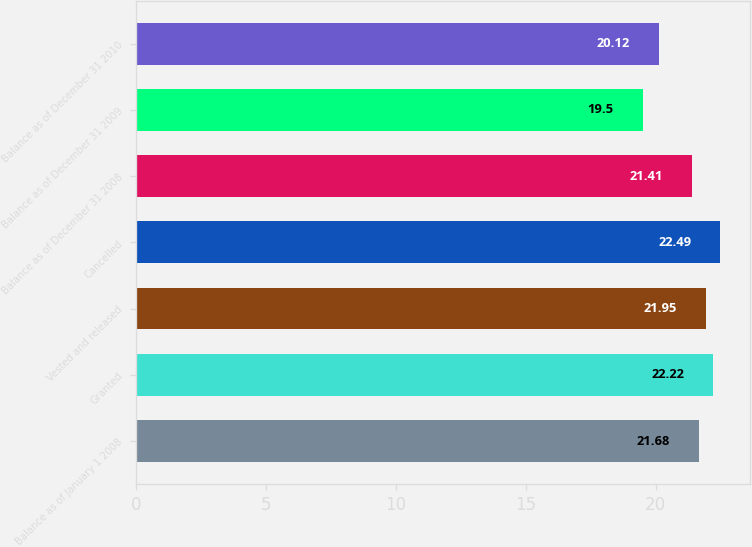Convert chart to OTSL. <chart><loc_0><loc_0><loc_500><loc_500><bar_chart><fcel>Balance as of January 1 2008<fcel>Granted<fcel>Vested and released<fcel>Cancelled<fcel>Balance as of December 31 2008<fcel>Balance as of December 31 2009<fcel>Balance as of December 31 2010<nl><fcel>21.68<fcel>22.22<fcel>21.95<fcel>22.49<fcel>21.41<fcel>19.5<fcel>20.12<nl></chart> 